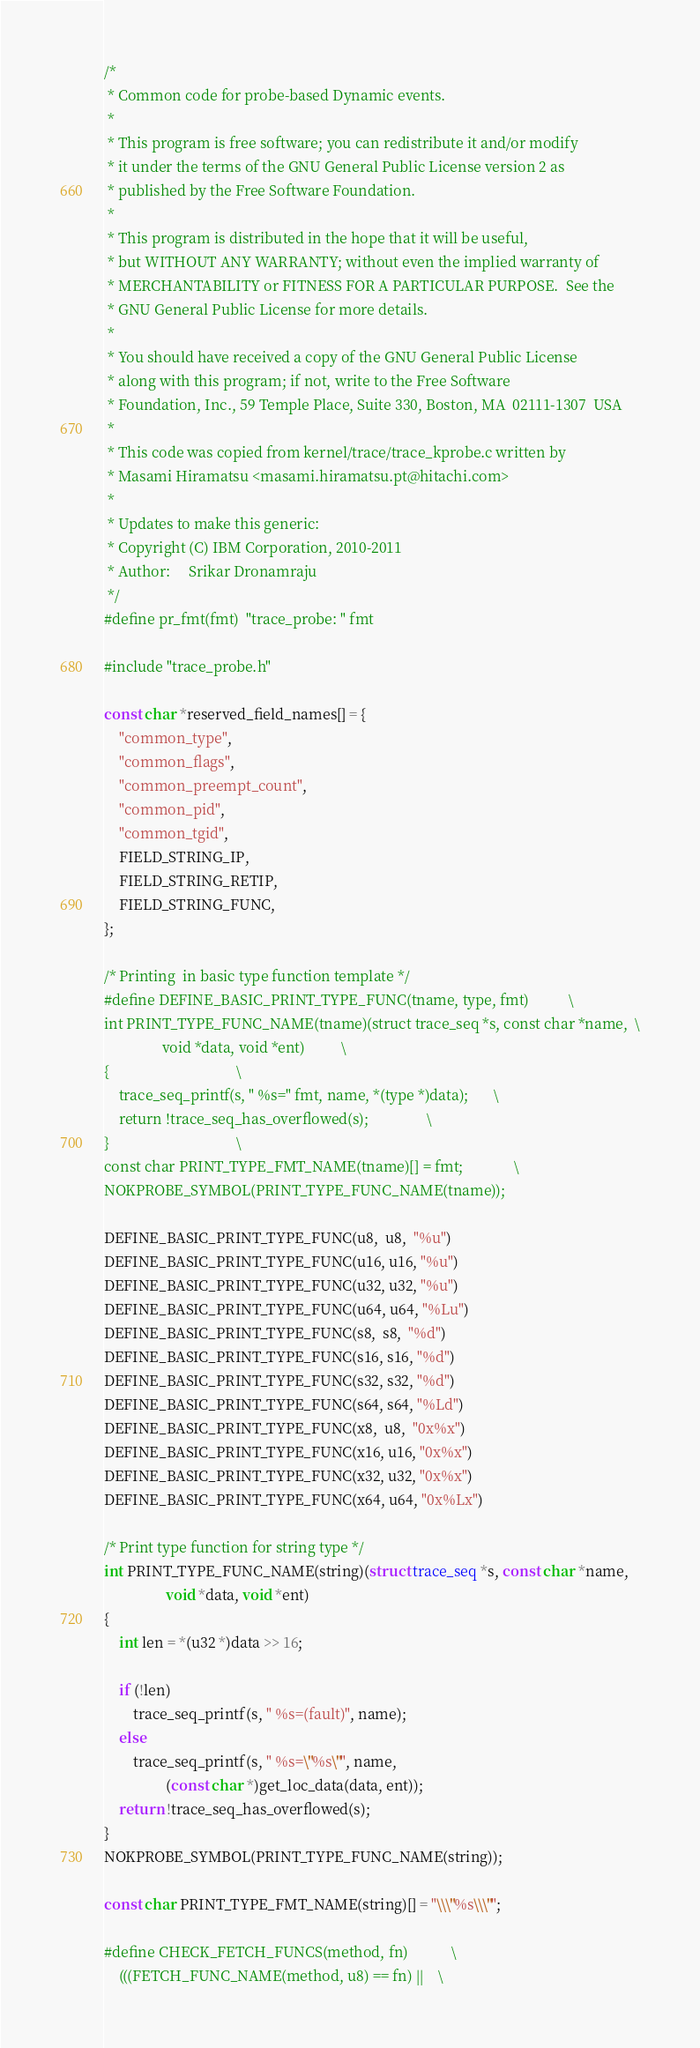Convert code to text. <code><loc_0><loc_0><loc_500><loc_500><_C_>/*
 * Common code for probe-based Dynamic events.
 *
 * This program is free software; you can redistribute it and/or modify
 * it under the terms of the GNU General Public License version 2 as
 * published by the Free Software Foundation.
 *
 * This program is distributed in the hope that it will be useful,
 * but WITHOUT ANY WARRANTY; without even the implied warranty of
 * MERCHANTABILITY or FITNESS FOR A PARTICULAR PURPOSE.  See the
 * GNU General Public License for more details.
 *
 * You should have received a copy of the GNU General Public License
 * along with this program; if not, write to the Free Software
 * Foundation, Inc., 59 Temple Place, Suite 330, Boston, MA  02111-1307  USA
 *
 * This code was copied from kernel/trace/trace_kprobe.c written by
 * Masami Hiramatsu <masami.hiramatsu.pt@hitachi.com>
 *
 * Updates to make this generic:
 * Copyright (C) IBM Corporation, 2010-2011
 * Author:     Srikar Dronamraju
 */
#define pr_fmt(fmt)	"trace_probe: " fmt

#include "trace_probe.h"

const char *reserved_field_names[] = {
	"common_type",
	"common_flags",
	"common_preempt_count",
	"common_pid",
	"common_tgid",
	FIELD_STRING_IP,
	FIELD_STRING_RETIP,
	FIELD_STRING_FUNC,
};

/* Printing  in basic type function template */
#define DEFINE_BASIC_PRINT_TYPE_FUNC(tname, type, fmt)			\
int PRINT_TYPE_FUNC_NAME(tname)(struct trace_seq *s, const char *name,	\
				void *data, void *ent)			\
{									\
	trace_seq_printf(s, " %s=" fmt, name, *(type *)data);		\
	return !trace_seq_has_overflowed(s);				\
}									\
const char PRINT_TYPE_FMT_NAME(tname)[] = fmt;				\
NOKPROBE_SYMBOL(PRINT_TYPE_FUNC_NAME(tname));

DEFINE_BASIC_PRINT_TYPE_FUNC(u8,  u8,  "%u")
DEFINE_BASIC_PRINT_TYPE_FUNC(u16, u16, "%u")
DEFINE_BASIC_PRINT_TYPE_FUNC(u32, u32, "%u")
DEFINE_BASIC_PRINT_TYPE_FUNC(u64, u64, "%Lu")
DEFINE_BASIC_PRINT_TYPE_FUNC(s8,  s8,  "%d")
DEFINE_BASIC_PRINT_TYPE_FUNC(s16, s16, "%d")
DEFINE_BASIC_PRINT_TYPE_FUNC(s32, s32, "%d")
DEFINE_BASIC_PRINT_TYPE_FUNC(s64, s64, "%Ld")
DEFINE_BASIC_PRINT_TYPE_FUNC(x8,  u8,  "0x%x")
DEFINE_BASIC_PRINT_TYPE_FUNC(x16, u16, "0x%x")
DEFINE_BASIC_PRINT_TYPE_FUNC(x32, u32, "0x%x")
DEFINE_BASIC_PRINT_TYPE_FUNC(x64, u64, "0x%Lx")

/* Print type function for string type */
int PRINT_TYPE_FUNC_NAME(string)(struct trace_seq *s, const char *name,
				 void *data, void *ent)
{
	int len = *(u32 *)data >> 16;

	if (!len)
		trace_seq_printf(s, " %s=(fault)", name);
	else
		trace_seq_printf(s, " %s=\"%s\"", name,
				 (const char *)get_loc_data(data, ent));
	return !trace_seq_has_overflowed(s);
}
NOKPROBE_SYMBOL(PRINT_TYPE_FUNC_NAME(string));

const char PRINT_TYPE_FMT_NAME(string)[] = "\\\"%s\\\"";

#define CHECK_FETCH_FUNCS(method, fn)			\
	(((FETCH_FUNC_NAME(method, u8) == fn) ||	\</code> 